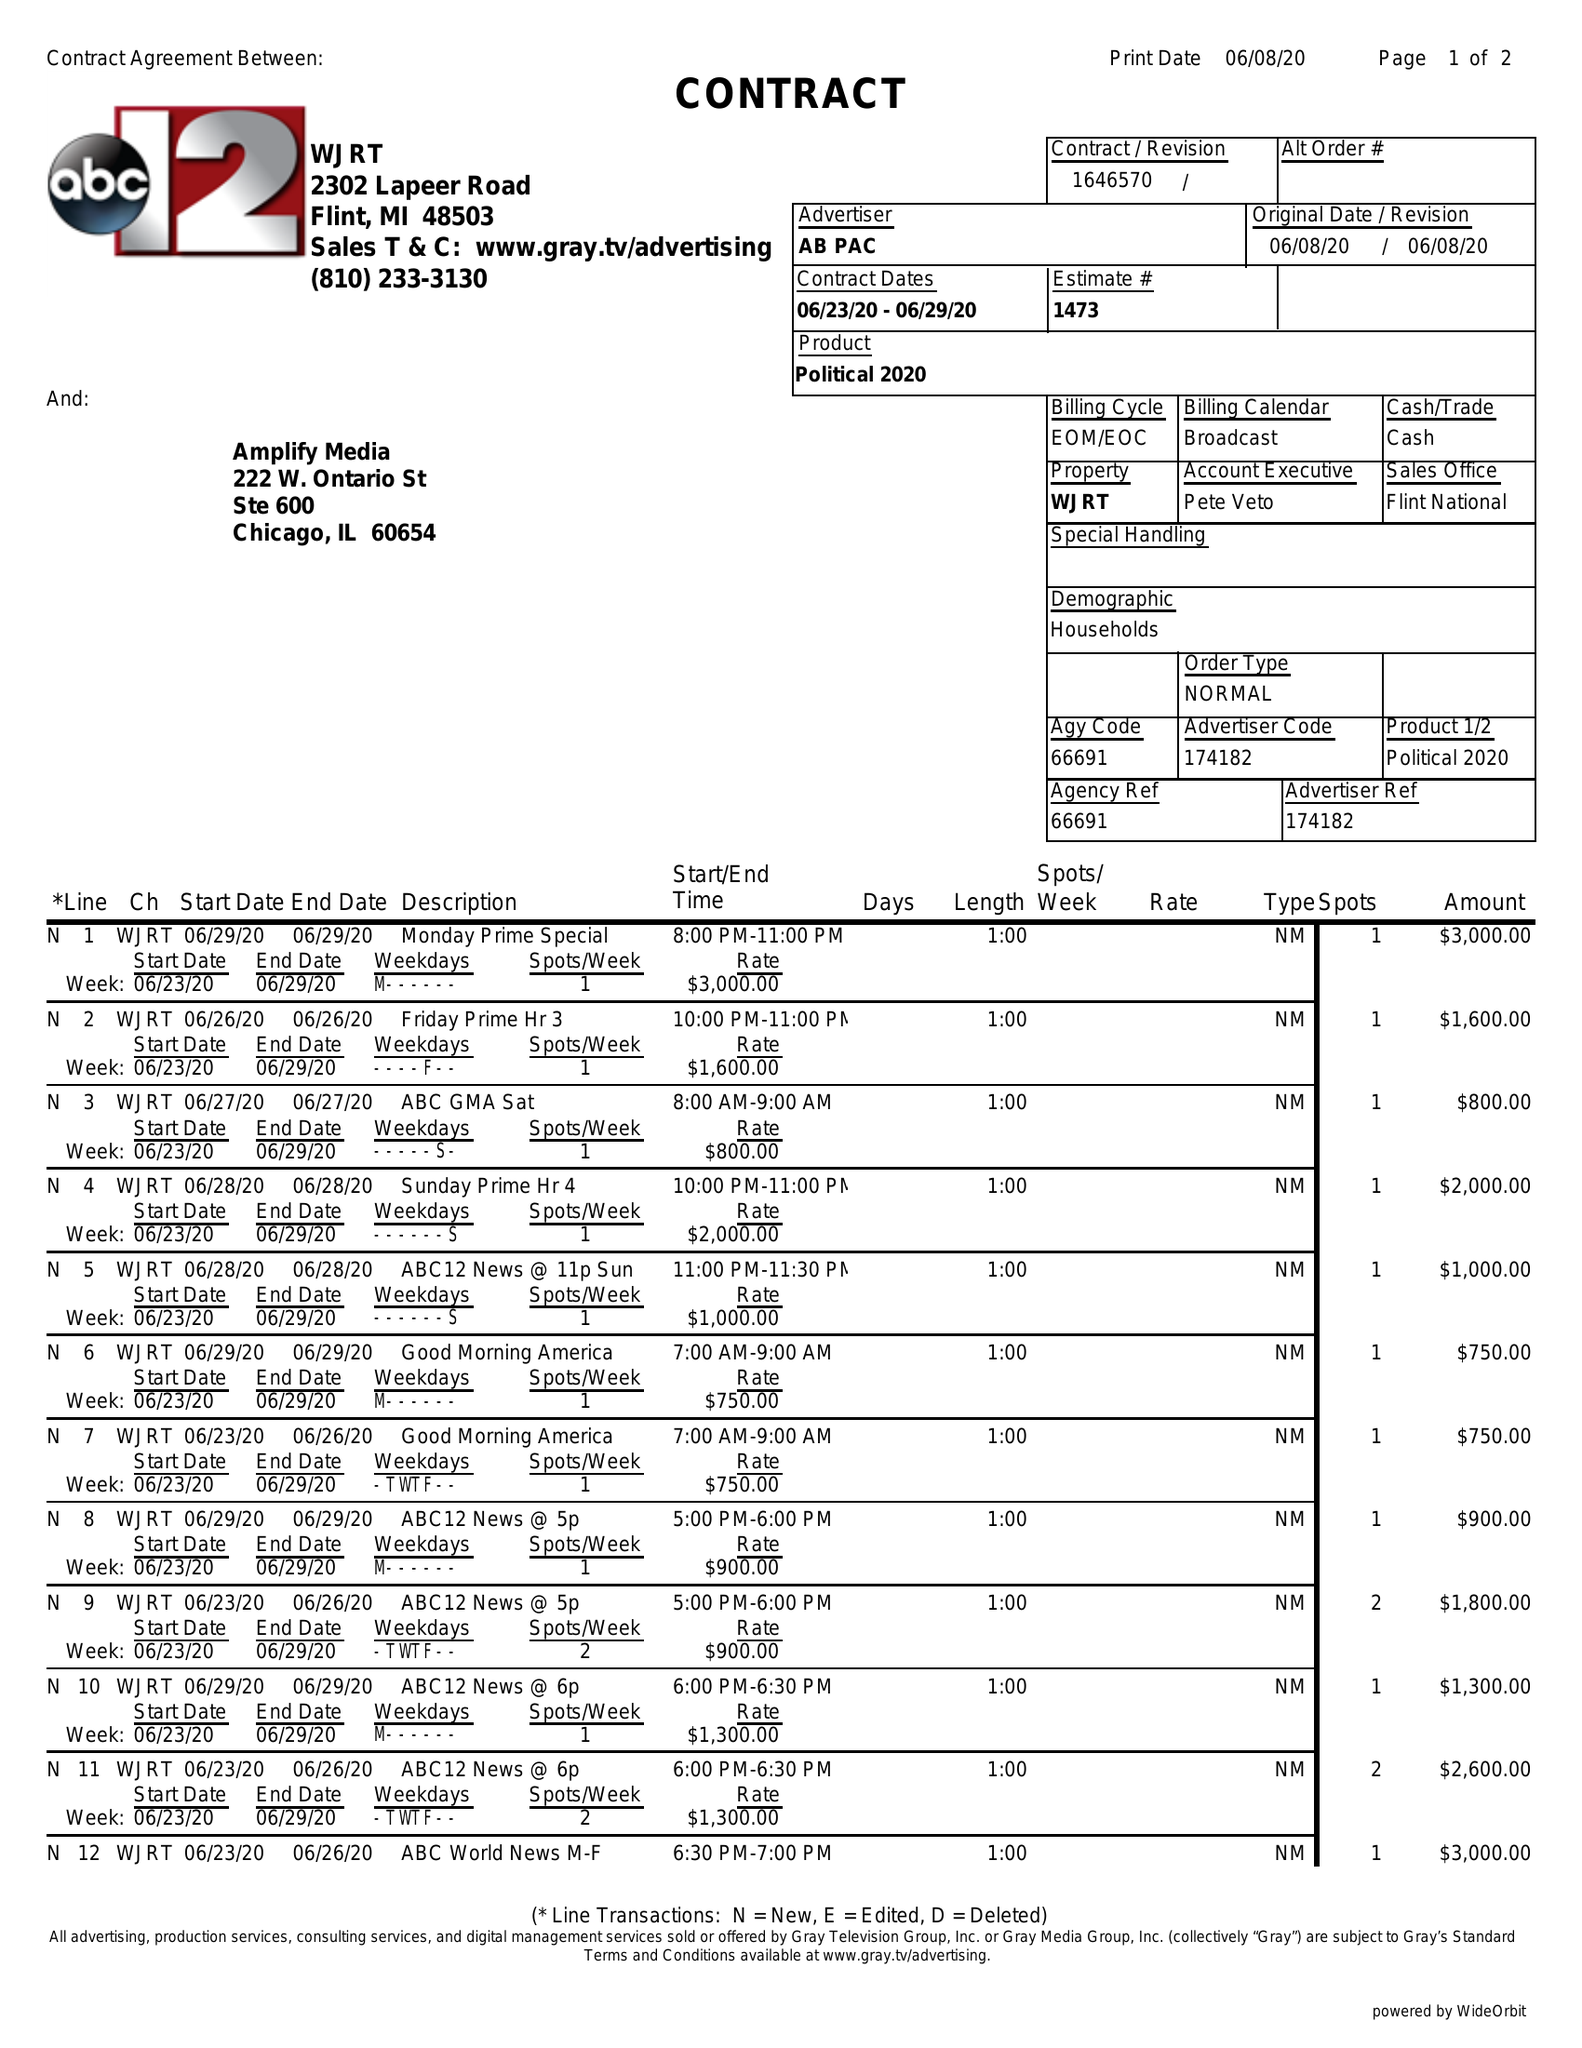What is the value for the advertiser?
Answer the question using a single word or phrase. AB PAC 